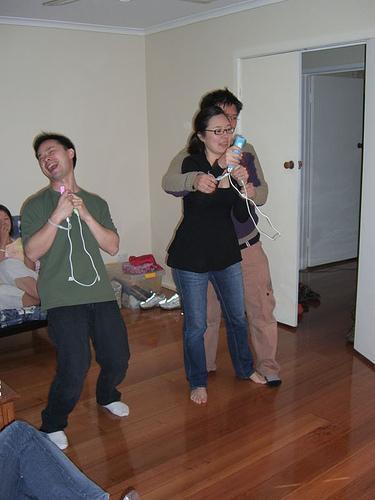How many people are present?
Give a very brief answer. 4. How many controllers are shown?
Give a very brief answer. 2. How many people are there?
Give a very brief answer. 5. How many people are in the picture?
Give a very brief answer. 5. 